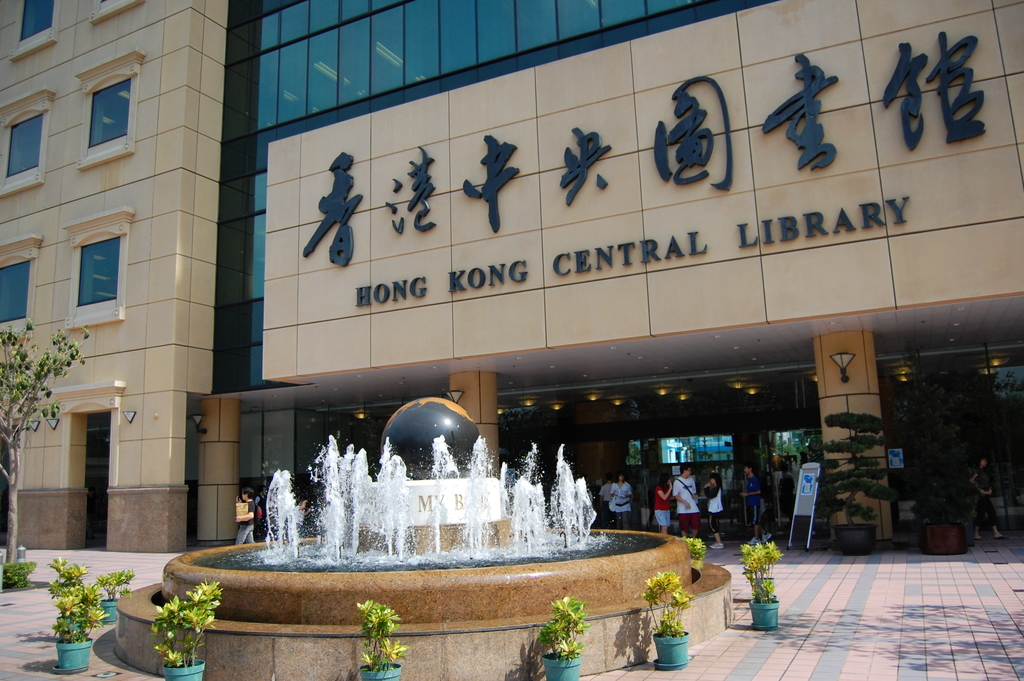Can you tell me more about the architectural style of the Hong Kong Central Library? The Hong Kong Central Library exhibits a contemporary architectural aesthetic characterized by its use of clean lines, large windows, and modern materials like glass and steel. The frontal facade displays a combination of stone tiles adding a timeless elegance to the structure. Designed with accessibility and environmental sustainability in mind, it embraces natural light and open spaces, making it a significant fixture in the urban landscape of Hong Kong. 